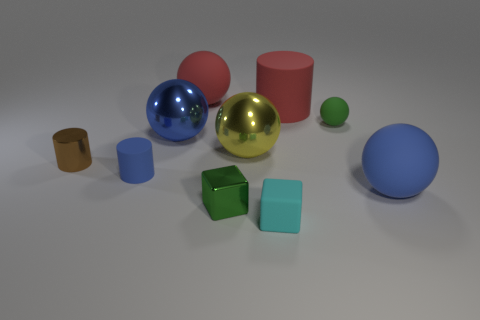The matte object that is the same color as the big cylinder is what size?
Make the answer very short. Large. There is a green object that is to the left of the block that is in front of the metal block; what number of blue balls are to the right of it?
Provide a short and direct response. 1. Are there any metallic blocks of the same color as the tiny ball?
Make the answer very short. Yes. What color is the other cube that is the same size as the green block?
Make the answer very short. Cyan. What is the shape of the red thing that is on the left side of the small metallic thing in front of the blue rubber thing that is on the right side of the tiny blue matte object?
Make the answer very short. Sphere. There is a large matte ball that is to the right of the big yellow metal ball; how many small green things are behind it?
Provide a short and direct response. 1. Does the green object that is behind the large yellow metallic object have the same shape as the small shiny thing right of the tiny rubber cylinder?
Offer a very short reply. No. How many tiny metallic cylinders are right of the large cylinder?
Your answer should be compact. 0. Is the big red object on the right side of the tiny green cube made of the same material as the tiny cyan thing?
Your answer should be very brief. Yes. There is another big shiny thing that is the same shape as the yellow object; what is its color?
Your response must be concise. Blue. 